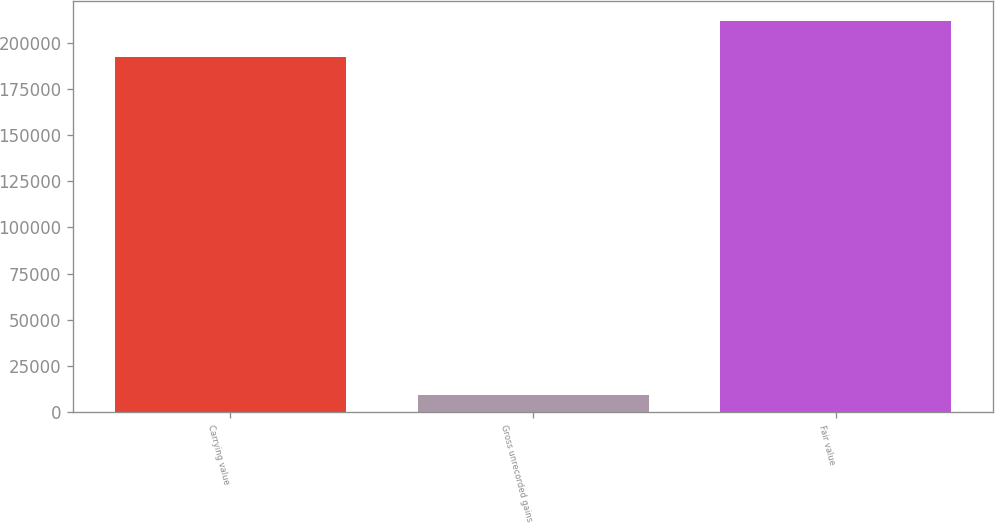Convert chart to OTSL. <chart><loc_0><loc_0><loc_500><loc_500><bar_chart><fcel>Carrying value<fcel>Gross unrecorded gains<fcel>Fair value<nl><fcel>192489<fcel>9576<fcel>211738<nl></chart> 